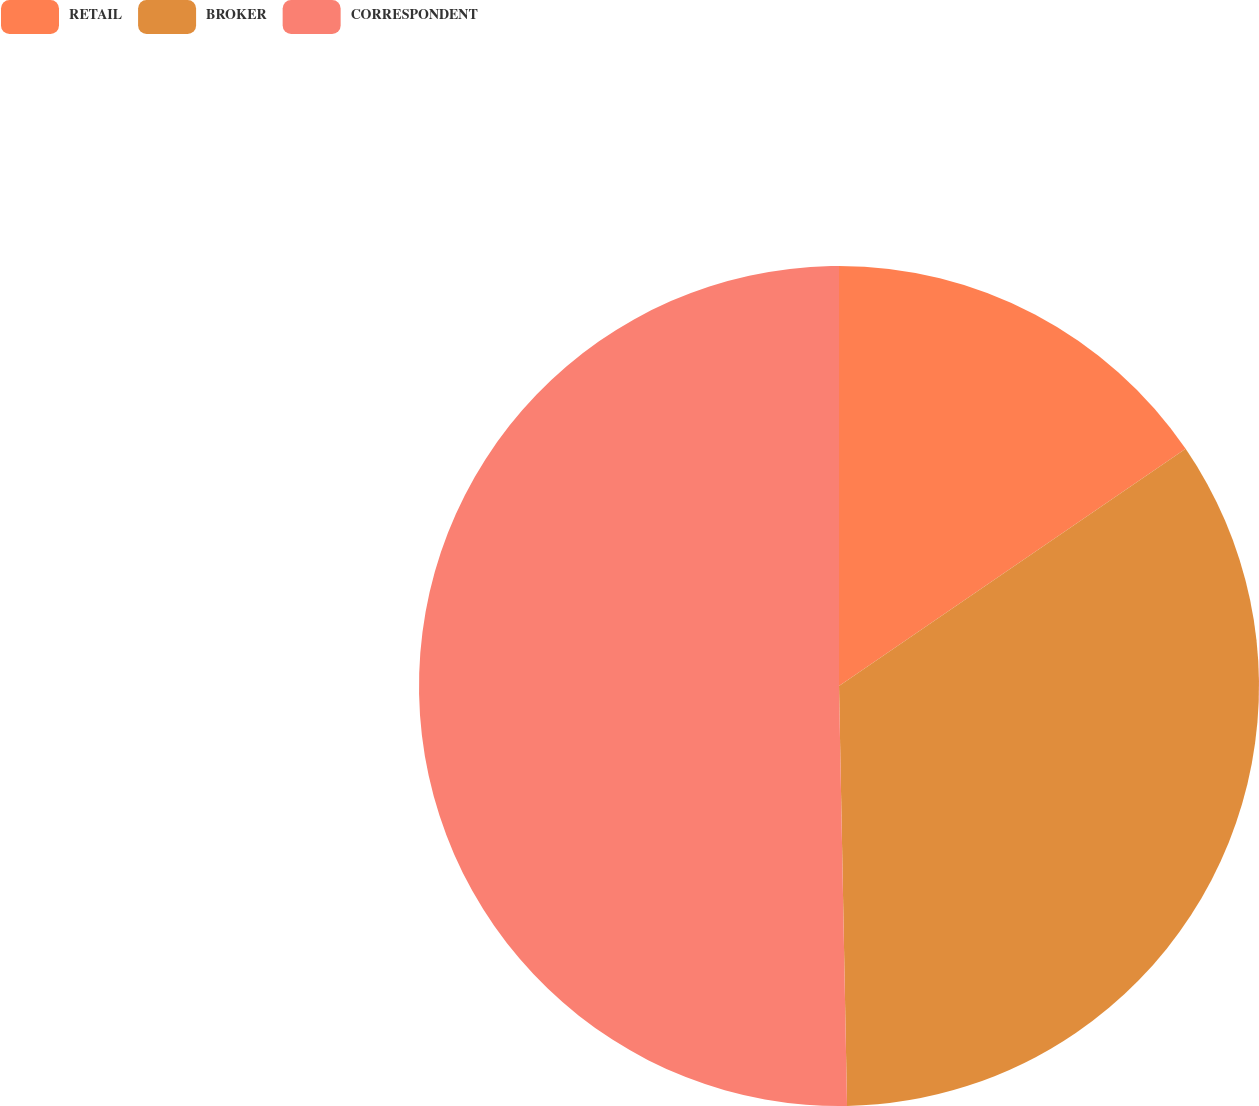Convert chart to OTSL. <chart><loc_0><loc_0><loc_500><loc_500><pie_chart><fcel>RETAIL<fcel>BROKER<fcel>CORRESPONDENT<nl><fcel>15.45%<fcel>34.24%<fcel>50.3%<nl></chart> 